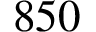<formula> <loc_0><loc_0><loc_500><loc_500>8 5 0</formula> 